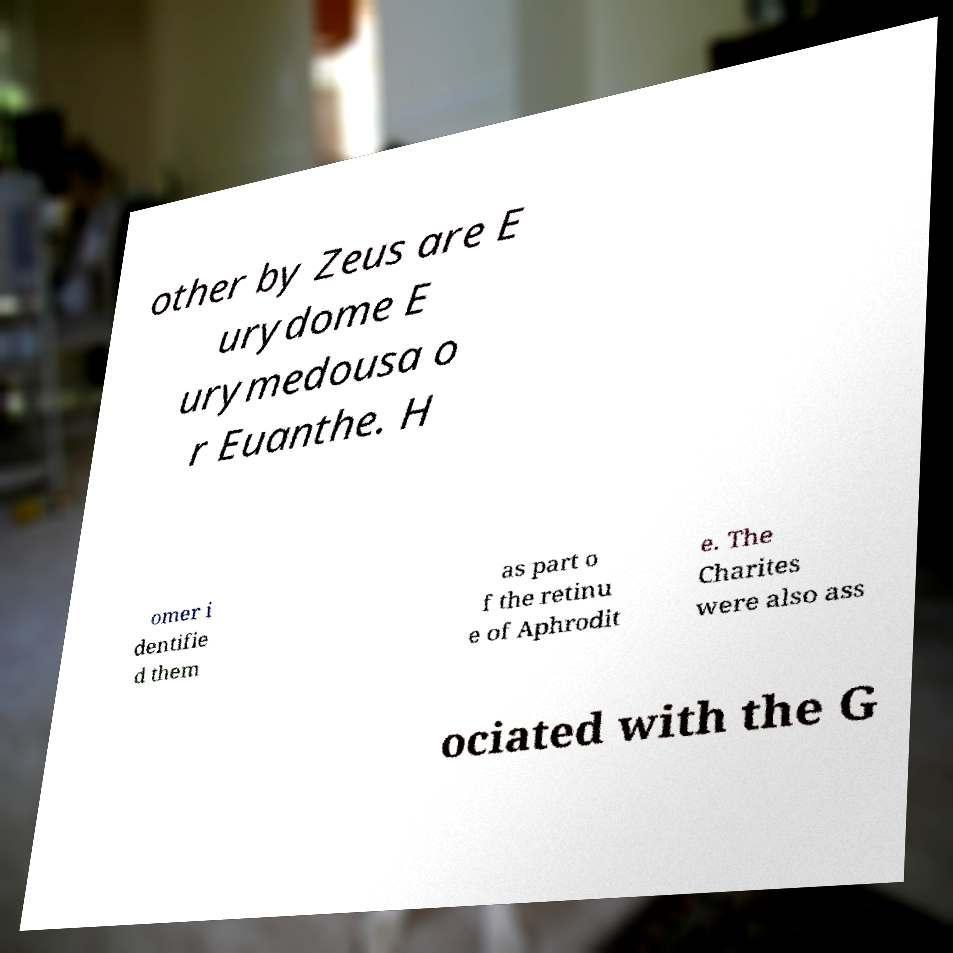Can you accurately transcribe the text from the provided image for me? other by Zeus are E urydome E urymedousa o r Euanthe. H omer i dentifie d them as part o f the retinu e of Aphrodit e. The Charites were also ass ociated with the G 